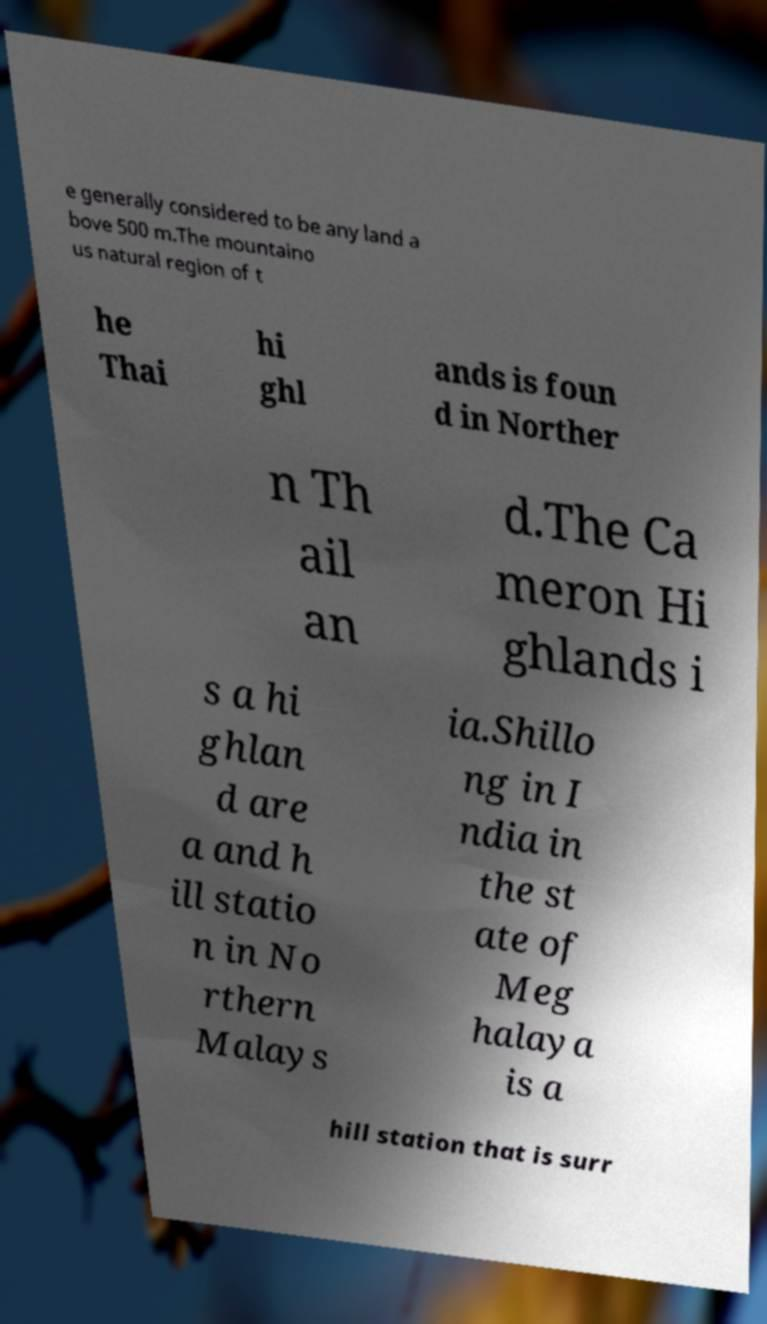Could you extract and type out the text from this image? e generally considered to be any land a bove 500 m.The mountaino us natural region of t he Thai hi ghl ands is foun d in Norther n Th ail an d.The Ca meron Hi ghlands i s a hi ghlan d are a and h ill statio n in No rthern Malays ia.Shillo ng in I ndia in the st ate of Meg halaya is a hill station that is surr 